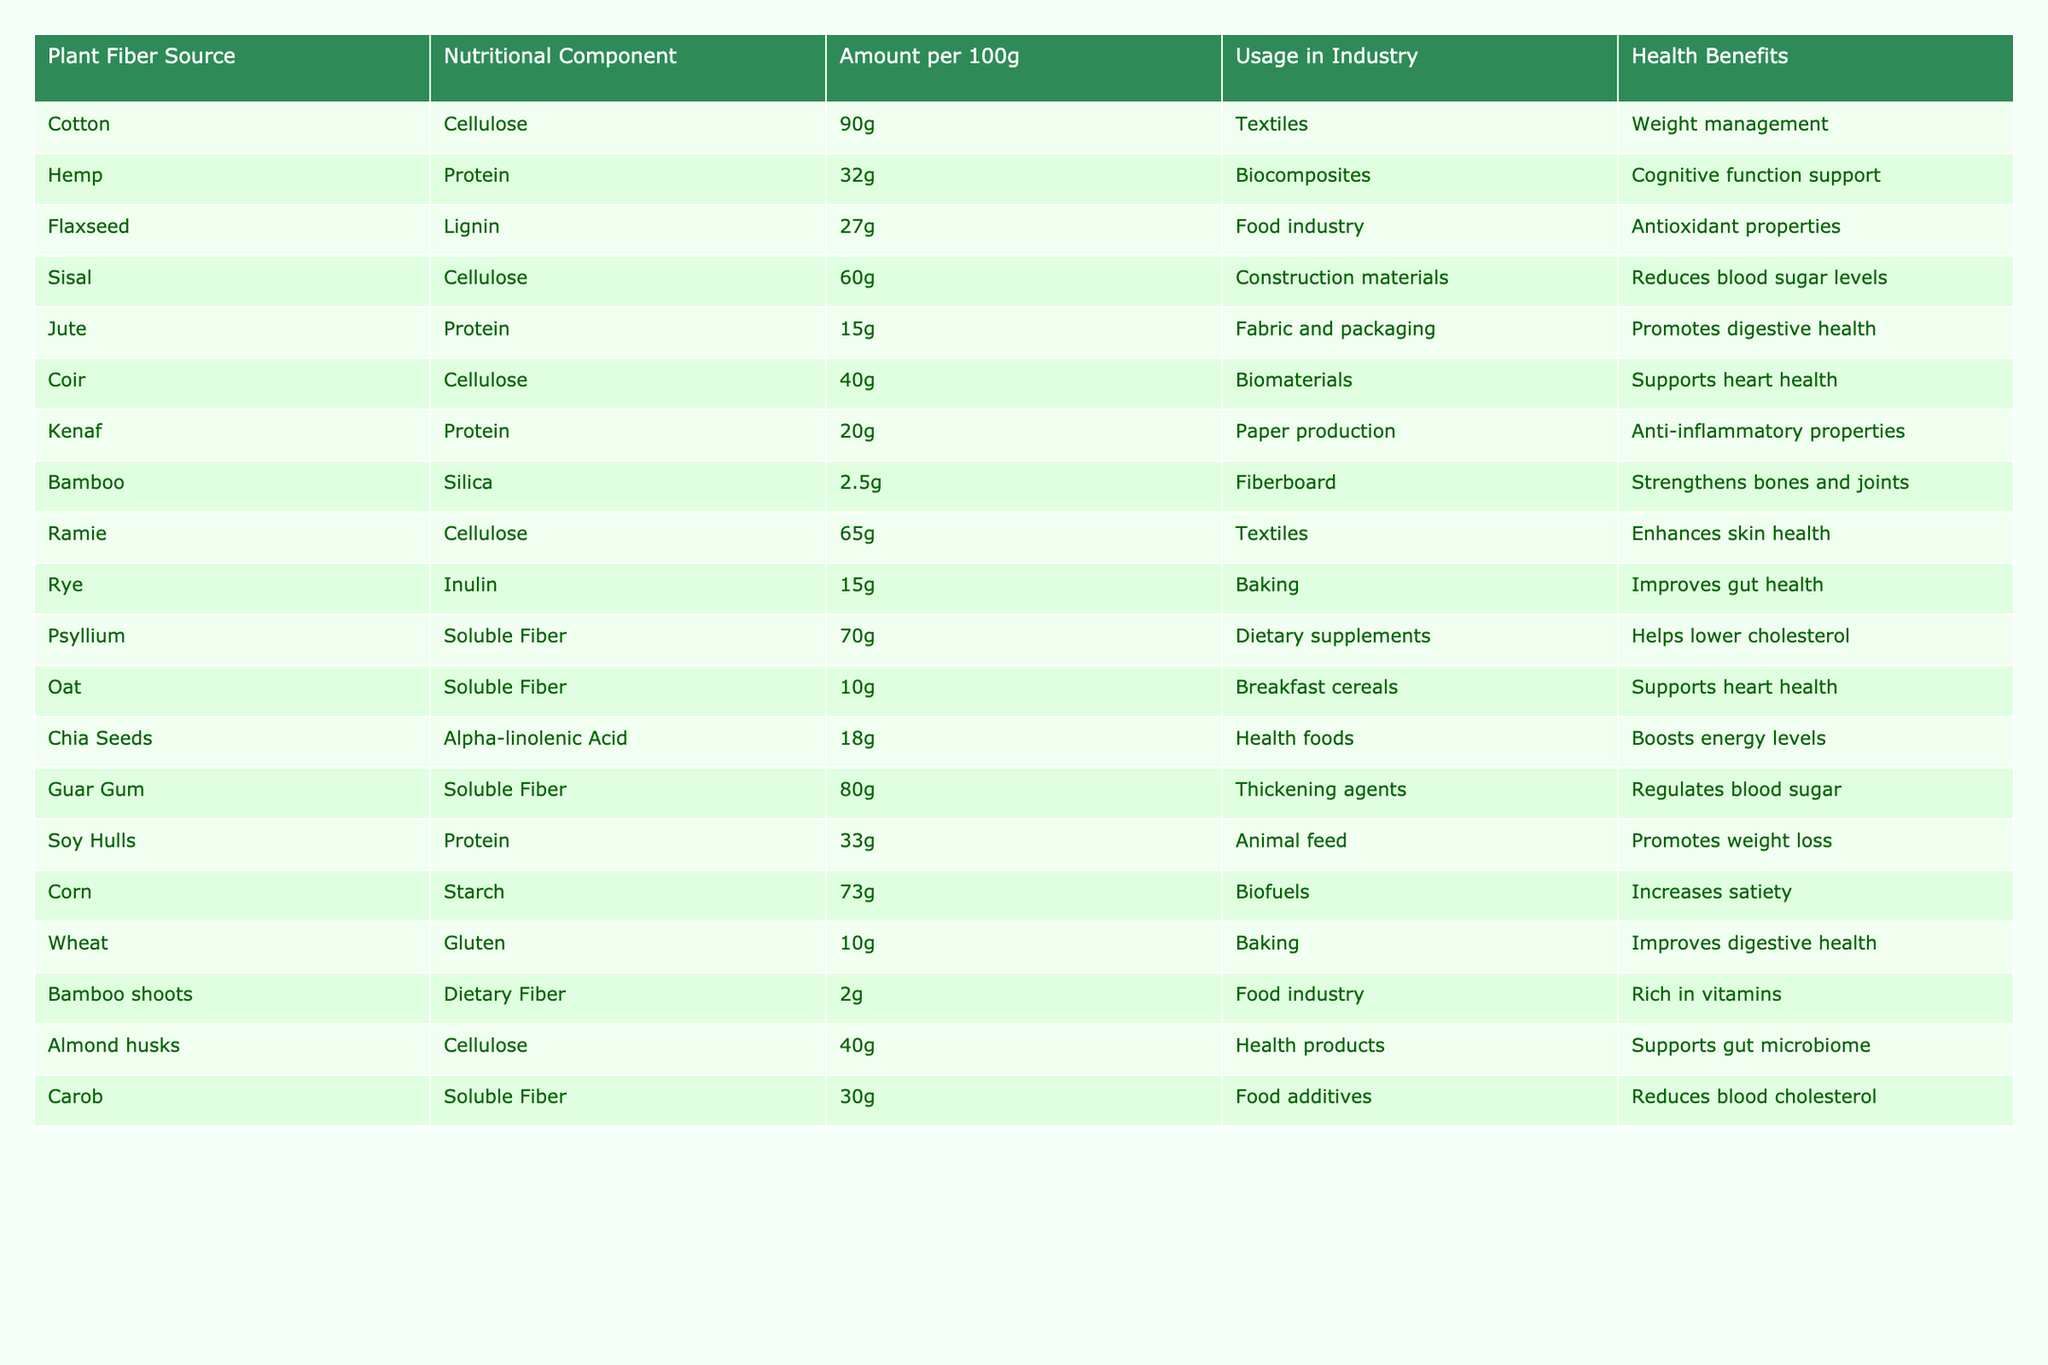What is the cellulose content in Ramie? The table indicates that Ramie contains 65g of cellulose per 100g.
Answer: 65g How many grams of protein does Hemp provide? According to the table, Hemp contains 32g of protein per 100g.
Answer: 32g Which plant fiber source has the highest amount of soluble fiber? Upon examining the table, Guar Gum has the highest soluble fiber content at 80g per 100g.
Answer: Guar Gum Is there a plant fiber source that provides 10g of gluten? The table shows that Wheat is the plant fiber source with 10g of gluten.
Answer: Yes What is the total protein content from Soy Hulls and Jute combined? The protein content for Soy Hulls is 33g and for Jute, it is 15g. Adding them gives a total protein content of 33 + 15 = 48g.
Answer: 48g Which plant fiber source is used in dietary supplements and what is its soluble fiber amount? The table shows that Psyllium is used in dietary supplements, providing 70g of soluble fiber per 100g.
Answer: 70g Which two plant fibers have the potential to support gut health? The table lists Rye (15g of Inulin) and Psyllium (70g of Soluble Fiber) as sources that promote gut health.
Answer: Rye and Psyllium What is the average cellulose content among Cotton, Sisal, Coir, and Ramie? The cellulose contents are 90g, 60g, 40g, and 65g respectively. The total is 90 + 60 + 40 + 65 = 255g. Dividing by 4 gives an average of 255/4 = 63.75g.
Answer: 63.75g How many plant fiber sources are used in the textile industry? From the table, Cotton and Ramie are the plant fiber sources indicated for use in the textile industry. This totals to two sources.
Answer: 2 What health benefit is associated with fiber from Chia Seeds? The table states that Chia Seeds provide the health benefit of boosting energy levels.
Answer: Boosts energy levels 